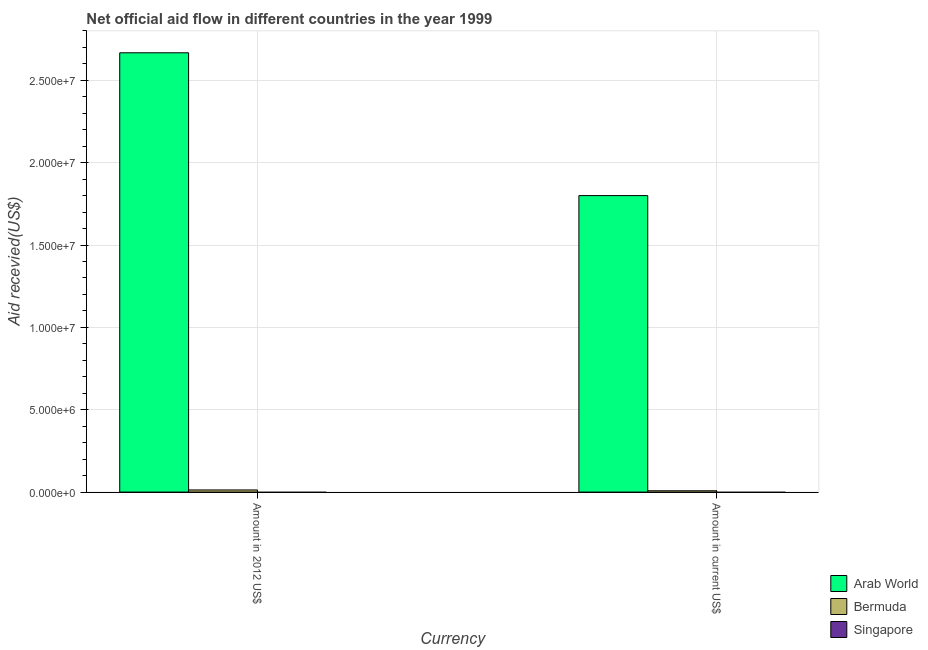Are the number of bars per tick equal to the number of legend labels?
Offer a very short reply. No. What is the label of the 2nd group of bars from the left?
Your answer should be compact. Amount in current US$. What is the amount of aid received(expressed in us$) in Singapore?
Ensure brevity in your answer.  0. Across all countries, what is the maximum amount of aid received(expressed in 2012 us$)?
Offer a very short reply. 2.67e+07. In which country was the amount of aid received(expressed in 2012 us$) maximum?
Keep it short and to the point. Arab World. What is the total amount of aid received(expressed in us$) in the graph?
Provide a short and direct response. 1.81e+07. What is the difference between the amount of aid received(expressed in us$) in Arab World and that in Bermuda?
Your response must be concise. 1.79e+07. What is the difference between the amount of aid received(expressed in 2012 us$) in Arab World and the amount of aid received(expressed in us$) in Bermuda?
Offer a terse response. 2.66e+07. What is the average amount of aid received(expressed in us$) per country?
Your answer should be very brief. 6.03e+06. What is the difference between the amount of aid received(expressed in us$) and amount of aid received(expressed in 2012 us$) in Arab World?
Your answer should be very brief. -8.67e+06. In how many countries, is the amount of aid received(expressed in us$) greater than 14000000 US$?
Your answer should be compact. 1. What is the ratio of the amount of aid received(expressed in us$) in Arab World to that in Bermuda?
Provide a short and direct response. 225. In how many countries, is the amount of aid received(expressed in 2012 us$) greater than the average amount of aid received(expressed in 2012 us$) taken over all countries?
Ensure brevity in your answer.  1. Are all the bars in the graph horizontal?
Offer a very short reply. No. Does the graph contain any zero values?
Ensure brevity in your answer.  Yes. Does the graph contain grids?
Your answer should be compact. Yes. Where does the legend appear in the graph?
Provide a short and direct response. Bottom right. What is the title of the graph?
Ensure brevity in your answer.  Net official aid flow in different countries in the year 1999. What is the label or title of the X-axis?
Your answer should be very brief. Currency. What is the label or title of the Y-axis?
Make the answer very short. Aid recevied(US$). What is the Aid recevied(US$) in Arab World in Amount in 2012 US$?
Your answer should be compact. 2.67e+07. What is the Aid recevied(US$) of Bermuda in Amount in 2012 US$?
Ensure brevity in your answer.  1.30e+05. What is the Aid recevied(US$) in Arab World in Amount in current US$?
Ensure brevity in your answer.  1.80e+07. What is the Aid recevied(US$) of Bermuda in Amount in current US$?
Your answer should be very brief. 8.00e+04. What is the Aid recevied(US$) in Singapore in Amount in current US$?
Offer a terse response. 0. Across all Currency, what is the maximum Aid recevied(US$) of Arab World?
Your response must be concise. 2.67e+07. Across all Currency, what is the maximum Aid recevied(US$) of Bermuda?
Your answer should be compact. 1.30e+05. Across all Currency, what is the minimum Aid recevied(US$) of Arab World?
Provide a succinct answer. 1.80e+07. What is the total Aid recevied(US$) of Arab World in the graph?
Offer a very short reply. 4.47e+07. What is the difference between the Aid recevied(US$) in Arab World in Amount in 2012 US$ and that in Amount in current US$?
Make the answer very short. 8.67e+06. What is the difference between the Aid recevied(US$) in Bermuda in Amount in 2012 US$ and that in Amount in current US$?
Ensure brevity in your answer.  5.00e+04. What is the difference between the Aid recevied(US$) in Arab World in Amount in 2012 US$ and the Aid recevied(US$) in Bermuda in Amount in current US$?
Provide a short and direct response. 2.66e+07. What is the average Aid recevied(US$) in Arab World per Currency?
Give a very brief answer. 2.23e+07. What is the average Aid recevied(US$) in Bermuda per Currency?
Keep it short and to the point. 1.05e+05. What is the average Aid recevied(US$) of Singapore per Currency?
Provide a short and direct response. 0. What is the difference between the Aid recevied(US$) in Arab World and Aid recevied(US$) in Bermuda in Amount in 2012 US$?
Keep it short and to the point. 2.65e+07. What is the difference between the Aid recevied(US$) in Arab World and Aid recevied(US$) in Bermuda in Amount in current US$?
Make the answer very short. 1.79e+07. What is the ratio of the Aid recevied(US$) in Arab World in Amount in 2012 US$ to that in Amount in current US$?
Your answer should be compact. 1.48. What is the ratio of the Aid recevied(US$) in Bermuda in Amount in 2012 US$ to that in Amount in current US$?
Your answer should be very brief. 1.62. What is the difference between the highest and the second highest Aid recevied(US$) in Arab World?
Provide a succinct answer. 8.67e+06. What is the difference between the highest and the second highest Aid recevied(US$) in Bermuda?
Your response must be concise. 5.00e+04. What is the difference between the highest and the lowest Aid recevied(US$) of Arab World?
Ensure brevity in your answer.  8.67e+06. What is the difference between the highest and the lowest Aid recevied(US$) of Bermuda?
Give a very brief answer. 5.00e+04. 